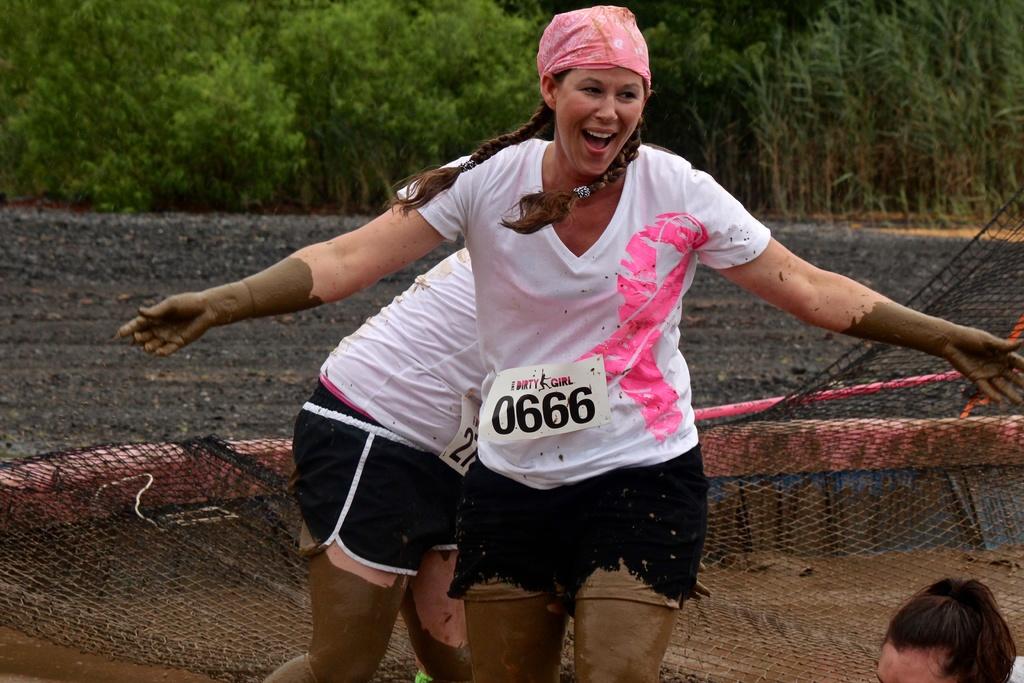What's her running tag number?
Your answer should be compact. 0666. What does it say above the tag number?
Give a very brief answer. Dirty girl. 